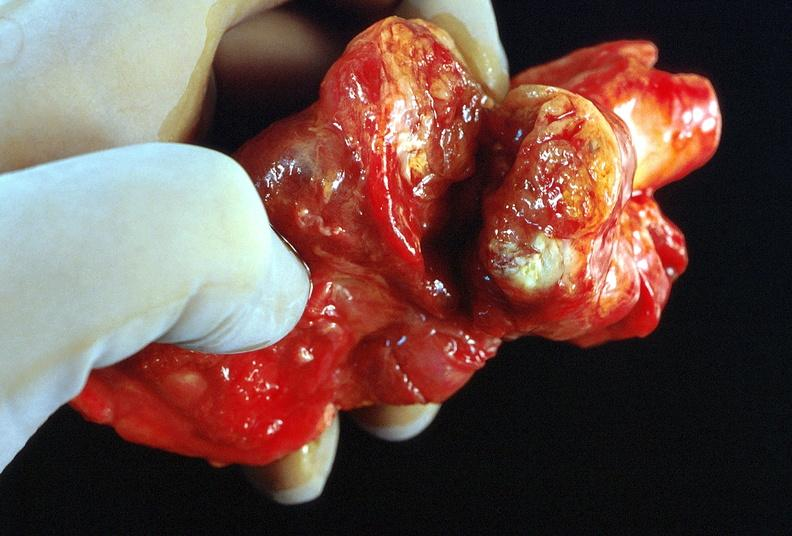where does this belong to?
Answer the question using a single word or phrase. Endocrine system 